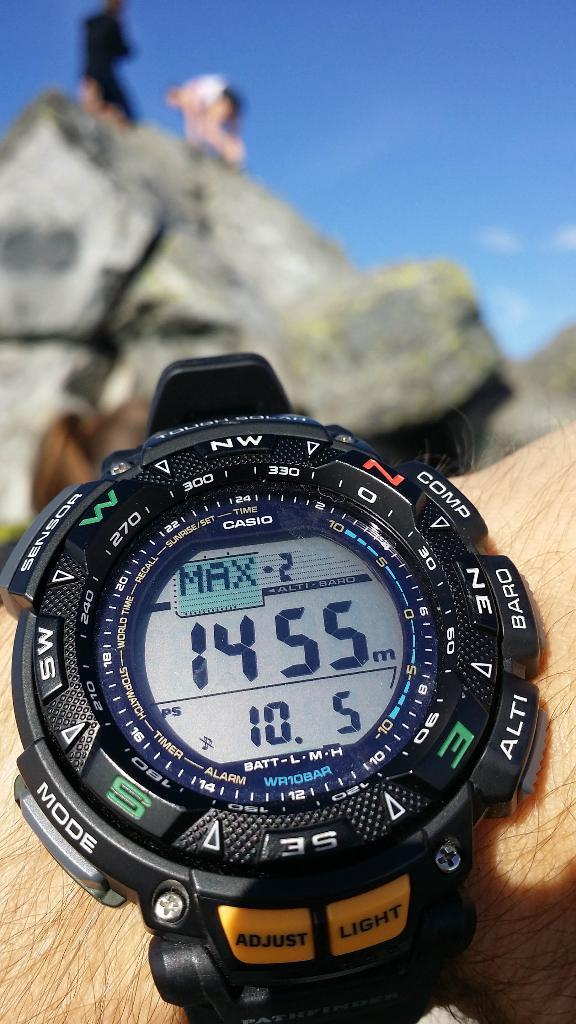<image>
Provide a brief description of the given image. a black watch that says 'max' on the screen of it 